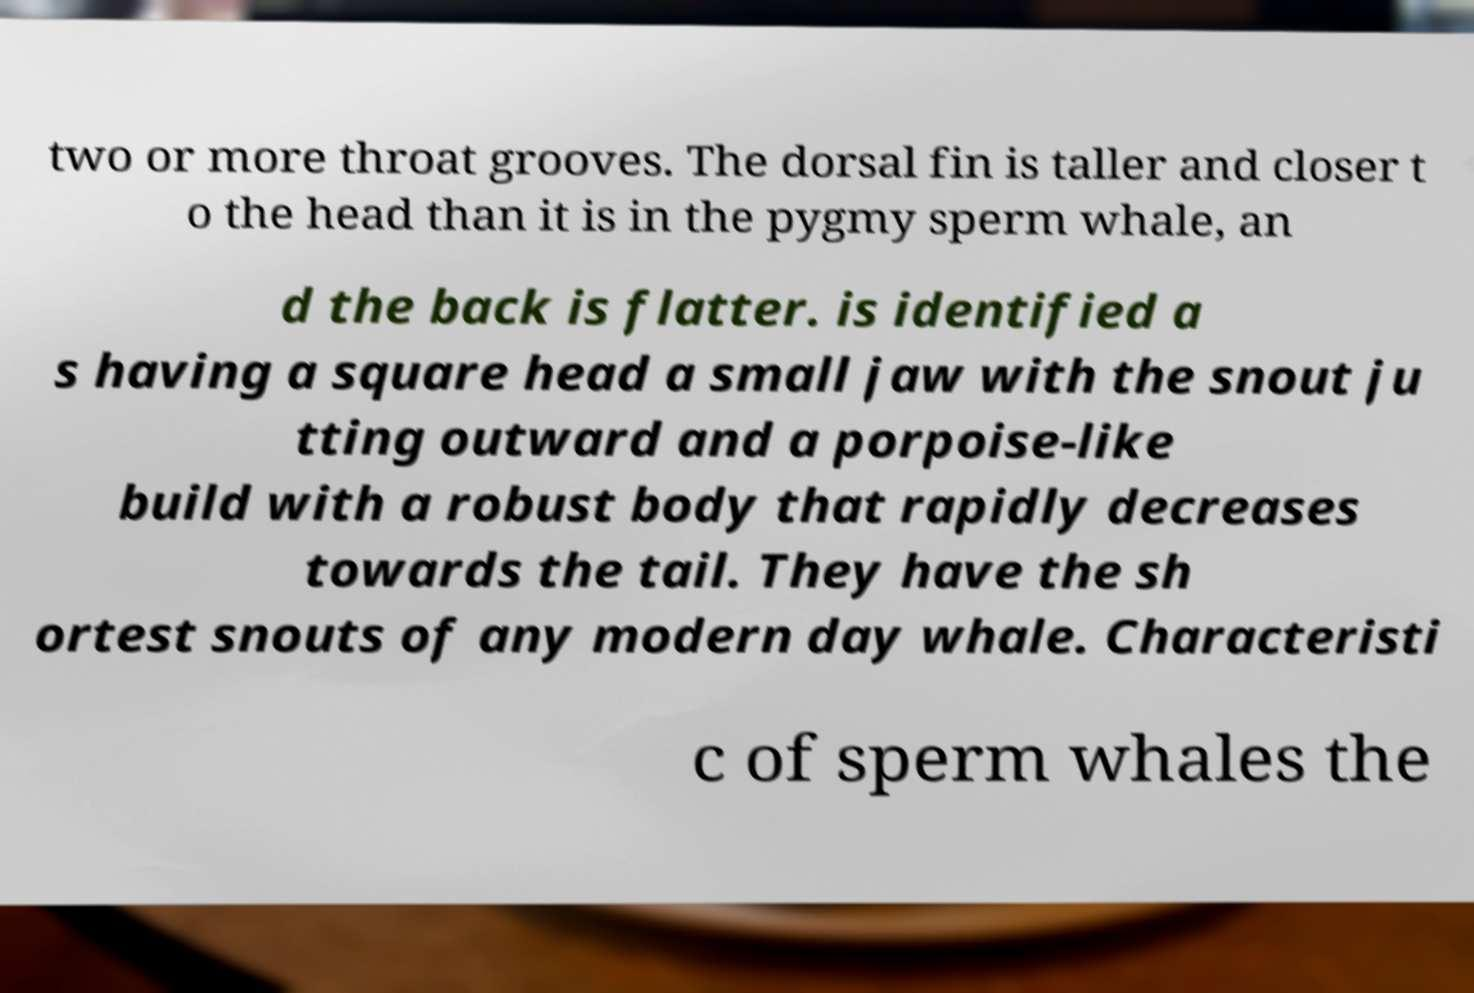Can you accurately transcribe the text from the provided image for me? two or more throat grooves. The dorsal fin is taller and closer t o the head than it is in the pygmy sperm whale, an d the back is flatter. is identified a s having a square head a small jaw with the snout ju tting outward and a porpoise-like build with a robust body that rapidly decreases towards the tail. They have the sh ortest snouts of any modern day whale. Characteristi c of sperm whales the 